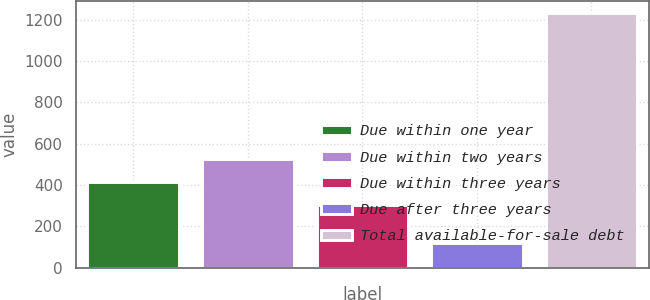<chart> <loc_0><loc_0><loc_500><loc_500><bar_chart><fcel>Due within one year<fcel>Due within two years<fcel>Due within three years<fcel>Due after three years<fcel>Total available-for-sale debt<nl><fcel>413.9<fcel>524.8<fcel>303<fcel>121<fcel>1230<nl></chart> 